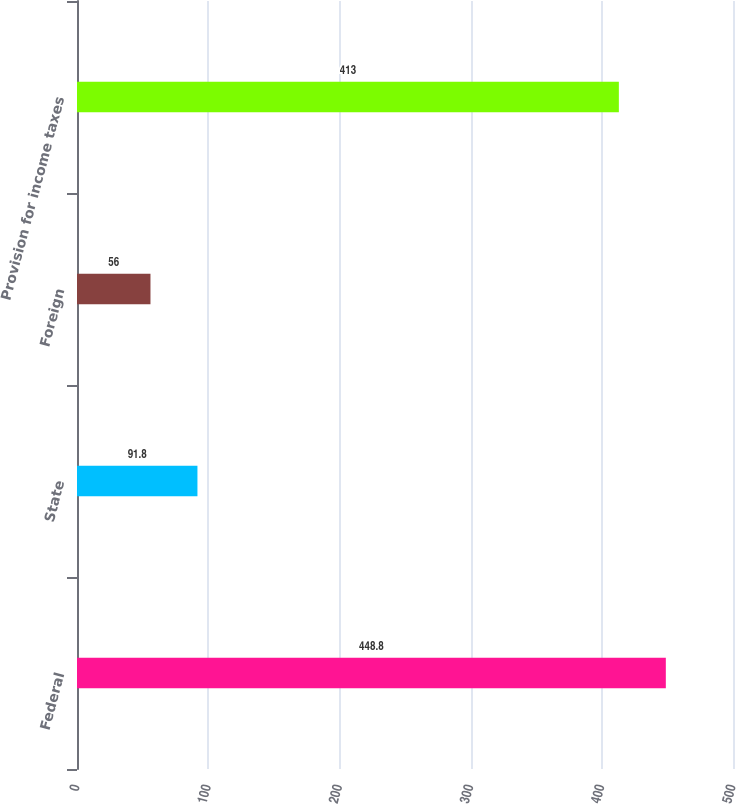<chart> <loc_0><loc_0><loc_500><loc_500><bar_chart><fcel>Federal<fcel>State<fcel>Foreign<fcel>Provision for income taxes<nl><fcel>448.8<fcel>91.8<fcel>56<fcel>413<nl></chart> 